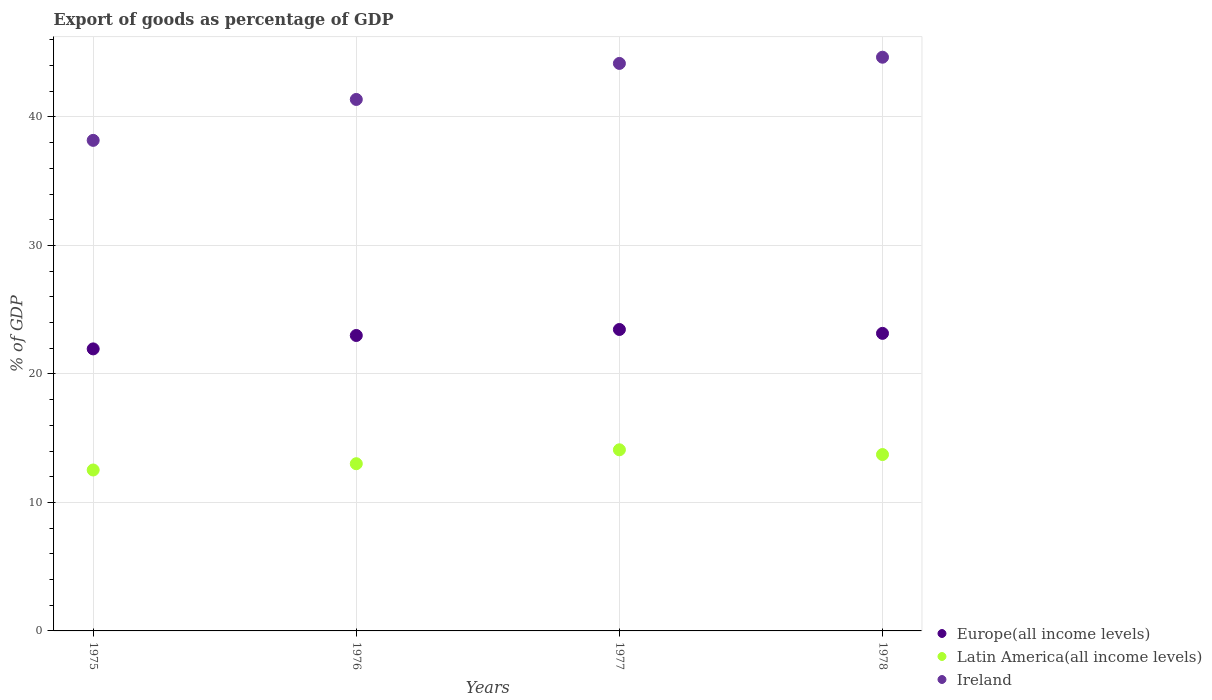Is the number of dotlines equal to the number of legend labels?
Your answer should be compact. Yes. What is the export of goods as percentage of GDP in Latin America(all income levels) in 1975?
Ensure brevity in your answer.  12.52. Across all years, what is the maximum export of goods as percentage of GDP in Latin America(all income levels)?
Your response must be concise. 14.1. Across all years, what is the minimum export of goods as percentage of GDP in Europe(all income levels)?
Provide a succinct answer. 21.95. In which year was the export of goods as percentage of GDP in Europe(all income levels) maximum?
Offer a terse response. 1977. In which year was the export of goods as percentage of GDP in Ireland minimum?
Keep it short and to the point. 1975. What is the total export of goods as percentage of GDP in Latin America(all income levels) in the graph?
Keep it short and to the point. 53.36. What is the difference between the export of goods as percentage of GDP in Latin America(all income levels) in 1977 and that in 1978?
Give a very brief answer. 0.37. What is the difference between the export of goods as percentage of GDP in Ireland in 1978 and the export of goods as percentage of GDP in Latin America(all income levels) in 1977?
Ensure brevity in your answer.  30.55. What is the average export of goods as percentage of GDP in Latin America(all income levels) per year?
Give a very brief answer. 13.34. In the year 1976, what is the difference between the export of goods as percentage of GDP in Latin America(all income levels) and export of goods as percentage of GDP in Europe(all income levels)?
Offer a very short reply. -9.98. In how many years, is the export of goods as percentage of GDP in Latin America(all income levels) greater than 18 %?
Offer a terse response. 0. What is the ratio of the export of goods as percentage of GDP in Europe(all income levels) in 1976 to that in 1977?
Make the answer very short. 0.98. Is the export of goods as percentage of GDP in Latin America(all income levels) in 1977 less than that in 1978?
Offer a terse response. No. Is the difference between the export of goods as percentage of GDP in Latin America(all income levels) in 1976 and 1977 greater than the difference between the export of goods as percentage of GDP in Europe(all income levels) in 1976 and 1977?
Keep it short and to the point. No. What is the difference between the highest and the second highest export of goods as percentage of GDP in Europe(all income levels)?
Offer a very short reply. 0.3. What is the difference between the highest and the lowest export of goods as percentage of GDP in Europe(all income levels)?
Offer a terse response. 1.51. In how many years, is the export of goods as percentage of GDP in Europe(all income levels) greater than the average export of goods as percentage of GDP in Europe(all income levels) taken over all years?
Your response must be concise. 3. Is the sum of the export of goods as percentage of GDP in Ireland in 1976 and 1978 greater than the maximum export of goods as percentage of GDP in Europe(all income levels) across all years?
Provide a succinct answer. Yes. Does the export of goods as percentage of GDP in Latin America(all income levels) monotonically increase over the years?
Your response must be concise. No. Is the export of goods as percentage of GDP in Latin America(all income levels) strictly greater than the export of goods as percentage of GDP in Ireland over the years?
Offer a very short reply. No. What is the difference between two consecutive major ticks on the Y-axis?
Provide a short and direct response. 10. Are the values on the major ticks of Y-axis written in scientific E-notation?
Your answer should be very brief. No. Does the graph contain any zero values?
Ensure brevity in your answer.  No. Where does the legend appear in the graph?
Offer a very short reply. Bottom right. How many legend labels are there?
Offer a terse response. 3. How are the legend labels stacked?
Keep it short and to the point. Vertical. What is the title of the graph?
Offer a very short reply. Export of goods as percentage of GDP. Does "Morocco" appear as one of the legend labels in the graph?
Provide a succinct answer. No. What is the label or title of the X-axis?
Your answer should be very brief. Years. What is the label or title of the Y-axis?
Offer a terse response. % of GDP. What is the % of GDP in Europe(all income levels) in 1975?
Your answer should be very brief. 21.95. What is the % of GDP of Latin America(all income levels) in 1975?
Give a very brief answer. 12.52. What is the % of GDP in Ireland in 1975?
Ensure brevity in your answer.  38.18. What is the % of GDP of Europe(all income levels) in 1976?
Make the answer very short. 22.99. What is the % of GDP in Latin America(all income levels) in 1976?
Keep it short and to the point. 13.01. What is the % of GDP in Ireland in 1976?
Give a very brief answer. 41.36. What is the % of GDP in Europe(all income levels) in 1977?
Make the answer very short. 23.46. What is the % of GDP of Latin America(all income levels) in 1977?
Your response must be concise. 14.1. What is the % of GDP in Ireland in 1977?
Provide a short and direct response. 44.17. What is the % of GDP in Europe(all income levels) in 1978?
Provide a short and direct response. 23.16. What is the % of GDP in Latin America(all income levels) in 1978?
Your response must be concise. 13.73. What is the % of GDP of Ireland in 1978?
Keep it short and to the point. 44.65. Across all years, what is the maximum % of GDP of Europe(all income levels)?
Provide a succinct answer. 23.46. Across all years, what is the maximum % of GDP of Latin America(all income levels)?
Make the answer very short. 14.1. Across all years, what is the maximum % of GDP in Ireland?
Provide a short and direct response. 44.65. Across all years, what is the minimum % of GDP of Europe(all income levels)?
Your answer should be very brief. 21.95. Across all years, what is the minimum % of GDP of Latin America(all income levels)?
Provide a succinct answer. 12.52. Across all years, what is the minimum % of GDP of Ireland?
Give a very brief answer. 38.18. What is the total % of GDP of Europe(all income levels) in the graph?
Make the answer very short. 91.56. What is the total % of GDP in Latin America(all income levels) in the graph?
Keep it short and to the point. 53.36. What is the total % of GDP in Ireland in the graph?
Your response must be concise. 168.36. What is the difference between the % of GDP in Europe(all income levels) in 1975 and that in 1976?
Your answer should be very brief. -1.04. What is the difference between the % of GDP of Latin America(all income levels) in 1975 and that in 1976?
Provide a succinct answer. -0.49. What is the difference between the % of GDP of Ireland in 1975 and that in 1976?
Make the answer very short. -3.18. What is the difference between the % of GDP of Europe(all income levels) in 1975 and that in 1977?
Ensure brevity in your answer.  -1.51. What is the difference between the % of GDP of Latin America(all income levels) in 1975 and that in 1977?
Offer a very short reply. -1.57. What is the difference between the % of GDP of Ireland in 1975 and that in 1977?
Your answer should be very brief. -5.99. What is the difference between the % of GDP in Europe(all income levels) in 1975 and that in 1978?
Make the answer very short. -1.21. What is the difference between the % of GDP of Latin America(all income levels) in 1975 and that in 1978?
Your answer should be very brief. -1.2. What is the difference between the % of GDP of Ireland in 1975 and that in 1978?
Provide a short and direct response. -6.47. What is the difference between the % of GDP of Europe(all income levels) in 1976 and that in 1977?
Your answer should be compact. -0.47. What is the difference between the % of GDP of Latin America(all income levels) in 1976 and that in 1977?
Provide a succinct answer. -1.08. What is the difference between the % of GDP of Ireland in 1976 and that in 1977?
Provide a succinct answer. -2.8. What is the difference between the % of GDP of Europe(all income levels) in 1976 and that in 1978?
Provide a short and direct response. -0.17. What is the difference between the % of GDP in Latin America(all income levels) in 1976 and that in 1978?
Offer a very short reply. -0.71. What is the difference between the % of GDP of Ireland in 1976 and that in 1978?
Give a very brief answer. -3.29. What is the difference between the % of GDP in Europe(all income levels) in 1977 and that in 1978?
Your answer should be very brief. 0.3. What is the difference between the % of GDP of Latin America(all income levels) in 1977 and that in 1978?
Offer a very short reply. 0.37. What is the difference between the % of GDP in Ireland in 1977 and that in 1978?
Make the answer very short. -0.48. What is the difference between the % of GDP of Europe(all income levels) in 1975 and the % of GDP of Latin America(all income levels) in 1976?
Your answer should be compact. 8.94. What is the difference between the % of GDP of Europe(all income levels) in 1975 and the % of GDP of Ireland in 1976?
Offer a very short reply. -19.41. What is the difference between the % of GDP of Latin America(all income levels) in 1975 and the % of GDP of Ireland in 1976?
Provide a short and direct response. -28.84. What is the difference between the % of GDP in Europe(all income levels) in 1975 and the % of GDP in Latin America(all income levels) in 1977?
Ensure brevity in your answer.  7.85. What is the difference between the % of GDP in Europe(all income levels) in 1975 and the % of GDP in Ireland in 1977?
Provide a short and direct response. -22.22. What is the difference between the % of GDP of Latin America(all income levels) in 1975 and the % of GDP of Ireland in 1977?
Keep it short and to the point. -31.64. What is the difference between the % of GDP in Europe(all income levels) in 1975 and the % of GDP in Latin America(all income levels) in 1978?
Offer a very short reply. 8.22. What is the difference between the % of GDP in Europe(all income levels) in 1975 and the % of GDP in Ireland in 1978?
Your response must be concise. -22.7. What is the difference between the % of GDP of Latin America(all income levels) in 1975 and the % of GDP of Ireland in 1978?
Make the answer very short. -32.13. What is the difference between the % of GDP of Europe(all income levels) in 1976 and the % of GDP of Latin America(all income levels) in 1977?
Offer a very short reply. 8.9. What is the difference between the % of GDP of Europe(all income levels) in 1976 and the % of GDP of Ireland in 1977?
Your answer should be compact. -21.17. What is the difference between the % of GDP of Latin America(all income levels) in 1976 and the % of GDP of Ireland in 1977?
Your response must be concise. -31.15. What is the difference between the % of GDP of Europe(all income levels) in 1976 and the % of GDP of Latin America(all income levels) in 1978?
Your answer should be compact. 9.27. What is the difference between the % of GDP in Europe(all income levels) in 1976 and the % of GDP in Ireland in 1978?
Give a very brief answer. -21.66. What is the difference between the % of GDP of Latin America(all income levels) in 1976 and the % of GDP of Ireland in 1978?
Offer a terse response. -31.64. What is the difference between the % of GDP in Europe(all income levels) in 1977 and the % of GDP in Latin America(all income levels) in 1978?
Offer a terse response. 9.73. What is the difference between the % of GDP of Europe(all income levels) in 1977 and the % of GDP of Ireland in 1978?
Your answer should be very brief. -21.19. What is the difference between the % of GDP of Latin America(all income levels) in 1977 and the % of GDP of Ireland in 1978?
Give a very brief answer. -30.55. What is the average % of GDP of Europe(all income levels) per year?
Ensure brevity in your answer.  22.89. What is the average % of GDP in Latin America(all income levels) per year?
Give a very brief answer. 13.34. What is the average % of GDP in Ireland per year?
Your answer should be compact. 42.09. In the year 1975, what is the difference between the % of GDP of Europe(all income levels) and % of GDP of Latin America(all income levels)?
Offer a very short reply. 9.43. In the year 1975, what is the difference between the % of GDP of Europe(all income levels) and % of GDP of Ireland?
Offer a terse response. -16.23. In the year 1975, what is the difference between the % of GDP of Latin America(all income levels) and % of GDP of Ireland?
Your response must be concise. -25.65. In the year 1976, what is the difference between the % of GDP in Europe(all income levels) and % of GDP in Latin America(all income levels)?
Offer a terse response. 9.98. In the year 1976, what is the difference between the % of GDP of Europe(all income levels) and % of GDP of Ireland?
Offer a terse response. -18.37. In the year 1976, what is the difference between the % of GDP of Latin America(all income levels) and % of GDP of Ireland?
Offer a terse response. -28.35. In the year 1977, what is the difference between the % of GDP in Europe(all income levels) and % of GDP in Latin America(all income levels)?
Your answer should be very brief. 9.36. In the year 1977, what is the difference between the % of GDP in Europe(all income levels) and % of GDP in Ireland?
Your answer should be very brief. -20.71. In the year 1977, what is the difference between the % of GDP in Latin America(all income levels) and % of GDP in Ireland?
Offer a very short reply. -30.07. In the year 1978, what is the difference between the % of GDP of Europe(all income levels) and % of GDP of Latin America(all income levels)?
Your answer should be compact. 9.43. In the year 1978, what is the difference between the % of GDP of Europe(all income levels) and % of GDP of Ireland?
Your answer should be compact. -21.49. In the year 1978, what is the difference between the % of GDP of Latin America(all income levels) and % of GDP of Ireland?
Your answer should be compact. -30.92. What is the ratio of the % of GDP in Europe(all income levels) in 1975 to that in 1976?
Offer a very short reply. 0.95. What is the ratio of the % of GDP of Latin America(all income levels) in 1975 to that in 1976?
Keep it short and to the point. 0.96. What is the ratio of the % of GDP of Ireland in 1975 to that in 1976?
Your answer should be very brief. 0.92. What is the ratio of the % of GDP in Europe(all income levels) in 1975 to that in 1977?
Your answer should be compact. 0.94. What is the ratio of the % of GDP in Latin America(all income levels) in 1975 to that in 1977?
Keep it short and to the point. 0.89. What is the ratio of the % of GDP in Ireland in 1975 to that in 1977?
Your response must be concise. 0.86. What is the ratio of the % of GDP of Europe(all income levels) in 1975 to that in 1978?
Provide a succinct answer. 0.95. What is the ratio of the % of GDP in Latin America(all income levels) in 1975 to that in 1978?
Keep it short and to the point. 0.91. What is the ratio of the % of GDP of Ireland in 1975 to that in 1978?
Your answer should be compact. 0.86. What is the ratio of the % of GDP of Europe(all income levels) in 1976 to that in 1977?
Ensure brevity in your answer.  0.98. What is the ratio of the % of GDP in Latin America(all income levels) in 1976 to that in 1977?
Make the answer very short. 0.92. What is the ratio of the % of GDP in Ireland in 1976 to that in 1977?
Give a very brief answer. 0.94. What is the ratio of the % of GDP in Europe(all income levels) in 1976 to that in 1978?
Ensure brevity in your answer.  0.99. What is the ratio of the % of GDP of Latin America(all income levels) in 1976 to that in 1978?
Your response must be concise. 0.95. What is the ratio of the % of GDP of Ireland in 1976 to that in 1978?
Give a very brief answer. 0.93. What is the ratio of the % of GDP of Latin America(all income levels) in 1977 to that in 1978?
Offer a very short reply. 1.03. What is the ratio of the % of GDP of Ireland in 1977 to that in 1978?
Your response must be concise. 0.99. What is the difference between the highest and the second highest % of GDP in Europe(all income levels)?
Ensure brevity in your answer.  0.3. What is the difference between the highest and the second highest % of GDP of Latin America(all income levels)?
Your answer should be very brief. 0.37. What is the difference between the highest and the second highest % of GDP in Ireland?
Provide a short and direct response. 0.48. What is the difference between the highest and the lowest % of GDP in Europe(all income levels)?
Give a very brief answer. 1.51. What is the difference between the highest and the lowest % of GDP in Latin America(all income levels)?
Offer a very short reply. 1.57. What is the difference between the highest and the lowest % of GDP in Ireland?
Offer a very short reply. 6.47. 